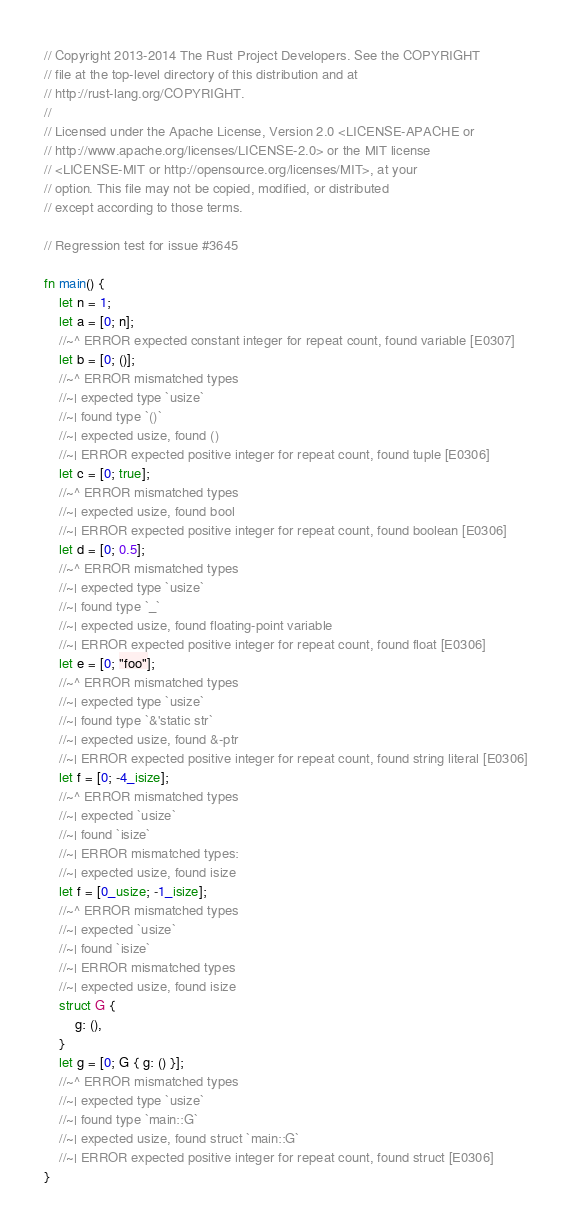<code> <loc_0><loc_0><loc_500><loc_500><_Rust_>// Copyright 2013-2014 The Rust Project Developers. See the COPYRIGHT
// file at the top-level directory of this distribution and at
// http://rust-lang.org/COPYRIGHT.
//
// Licensed under the Apache License, Version 2.0 <LICENSE-APACHE or
// http://www.apache.org/licenses/LICENSE-2.0> or the MIT license
// <LICENSE-MIT or http://opensource.org/licenses/MIT>, at your
// option. This file may not be copied, modified, or distributed
// except according to those terms.

// Regression test for issue #3645

fn main() {
    let n = 1;
    let a = [0; n];
    //~^ ERROR expected constant integer for repeat count, found variable [E0307]
    let b = [0; ()];
    //~^ ERROR mismatched types
    //~| expected type `usize`
    //~| found type `()`
    //~| expected usize, found ()
    //~| ERROR expected positive integer for repeat count, found tuple [E0306]
    let c = [0; true];
    //~^ ERROR mismatched types
    //~| expected usize, found bool
    //~| ERROR expected positive integer for repeat count, found boolean [E0306]
    let d = [0; 0.5];
    //~^ ERROR mismatched types
    //~| expected type `usize`
    //~| found type `_`
    //~| expected usize, found floating-point variable
    //~| ERROR expected positive integer for repeat count, found float [E0306]
    let e = [0; "foo"];
    //~^ ERROR mismatched types
    //~| expected type `usize`
    //~| found type `&'static str`
    //~| expected usize, found &-ptr
    //~| ERROR expected positive integer for repeat count, found string literal [E0306]
    let f = [0; -4_isize];
    //~^ ERROR mismatched types
    //~| expected `usize`
    //~| found `isize`
    //~| ERROR mismatched types:
    //~| expected usize, found isize
    let f = [0_usize; -1_isize];
    //~^ ERROR mismatched types
    //~| expected `usize`
    //~| found `isize`
    //~| ERROR mismatched types
    //~| expected usize, found isize
    struct G {
        g: (),
    }
    let g = [0; G { g: () }];
    //~^ ERROR mismatched types
    //~| expected type `usize`
    //~| found type `main::G`
    //~| expected usize, found struct `main::G`
    //~| ERROR expected positive integer for repeat count, found struct [E0306]
}
</code> 